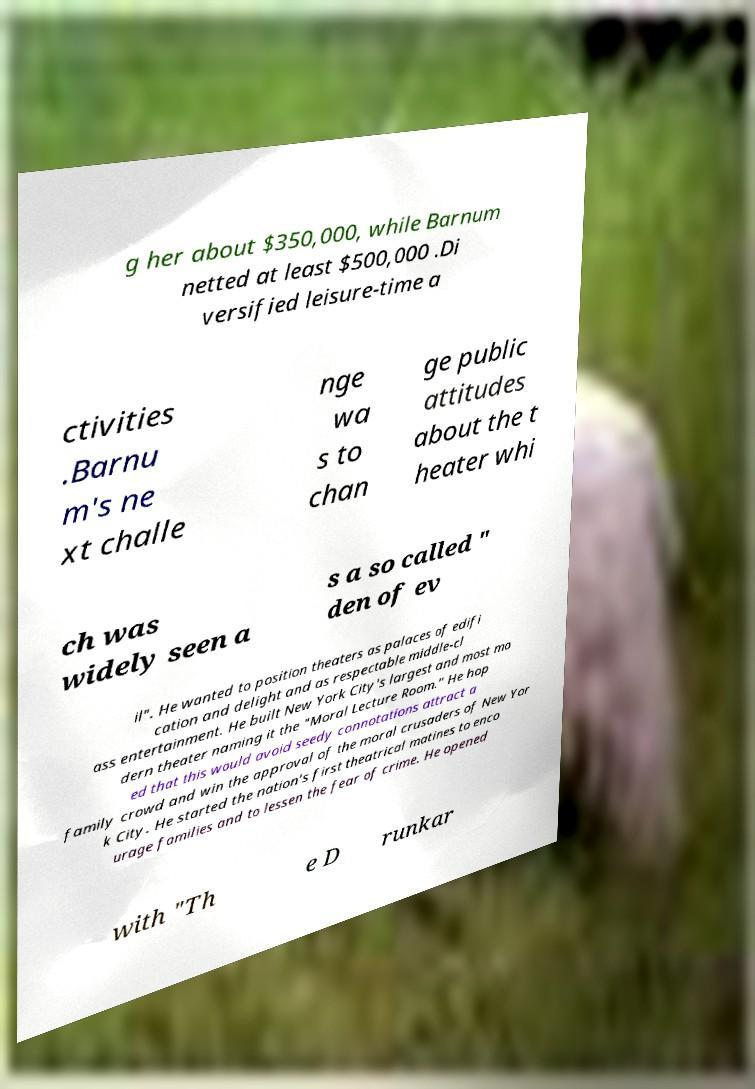Please identify and transcribe the text found in this image. g her about $350,000, while Barnum netted at least $500,000 .Di versified leisure-time a ctivities .Barnu m's ne xt challe nge wa s to chan ge public attitudes about the t heater whi ch was widely seen a s a so called " den of ev il". He wanted to position theaters as palaces of edifi cation and delight and as respectable middle-cl ass entertainment. He built New York City's largest and most mo dern theater naming it the "Moral Lecture Room." He hop ed that this would avoid seedy connotations attract a family crowd and win the approval of the moral crusaders of New Yor k City. He started the nation's first theatrical matines to enco urage families and to lessen the fear of crime. He opened with "Th e D runkar 